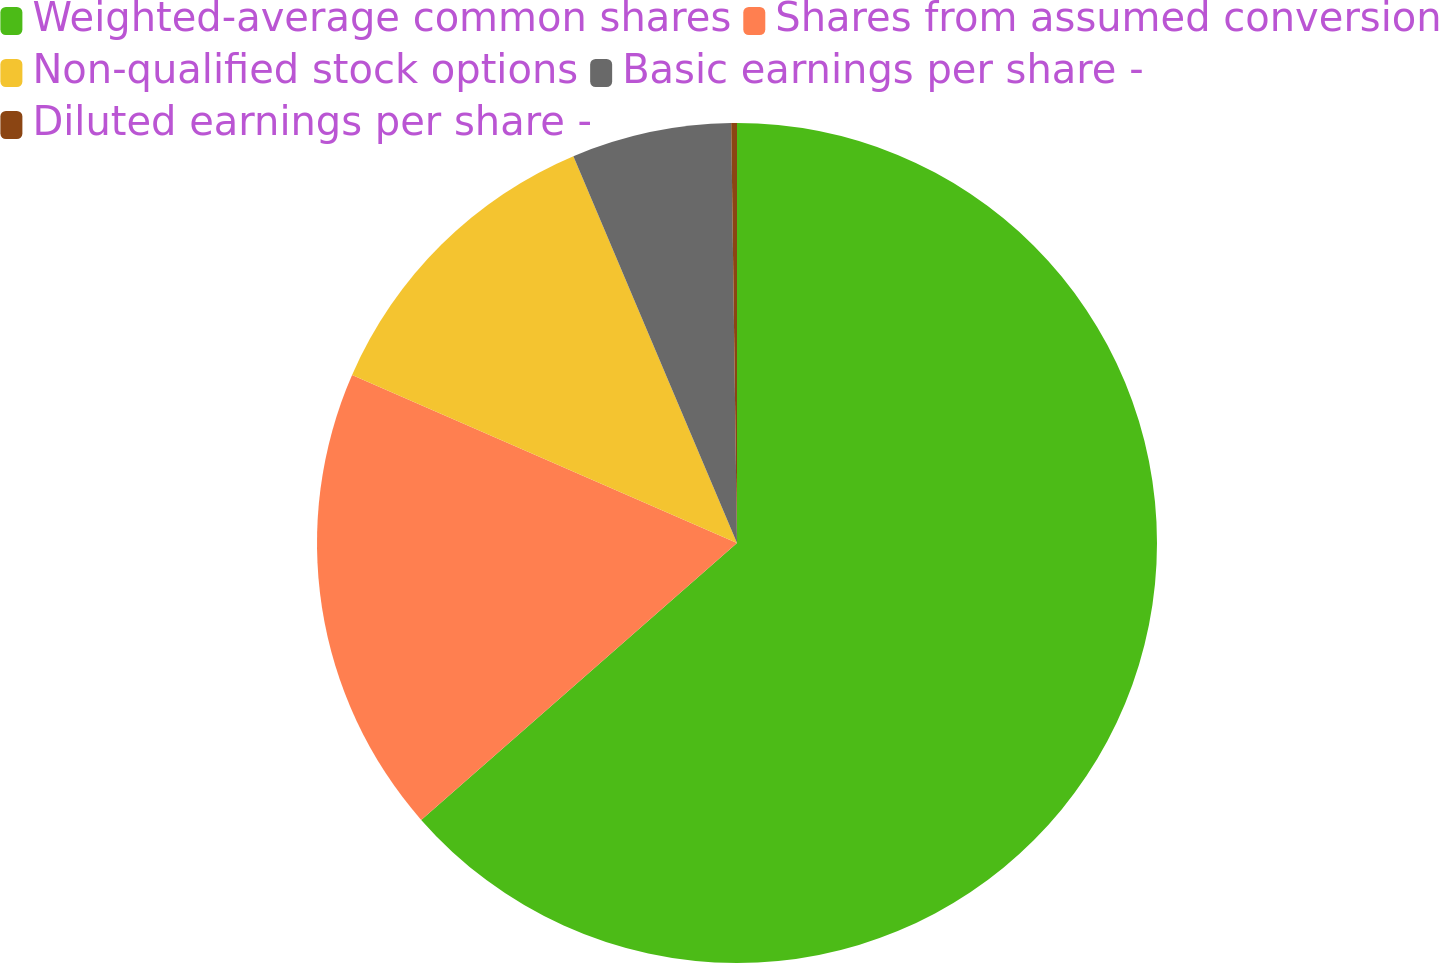Convert chart. <chart><loc_0><loc_0><loc_500><loc_500><pie_chart><fcel>Weighted-average common shares<fcel>Shares from assumed conversion<fcel>Non-qualified stock options<fcel>Basic earnings per share -<fcel>Diluted earnings per share -<nl><fcel>63.55%<fcel>18.01%<fcel>12.08%<fcel>6.15%<fcel>0.22%<nl></chart> 